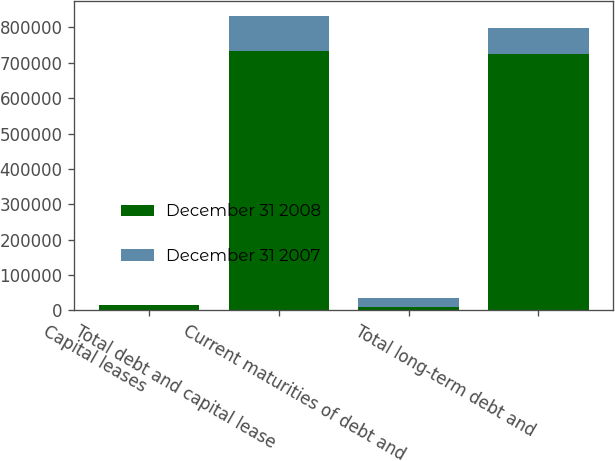<chart> <loc_0><loc_0><loc_500><loc_500><stacked_bar_chart><ecel><fcel>Capital leases<fcel>Total debt and capital lease<fcel>Current maturities of debt and<fcel>Total long-term debt and<nl><fcel>December 31 2008<fcel>14927<fcel>732695<fcel>8131<fcel>724564<nl><fcel>December 31 2007<fcel>469<fcel>100469<fcel>25320<fcel>75149<nl></chart> 